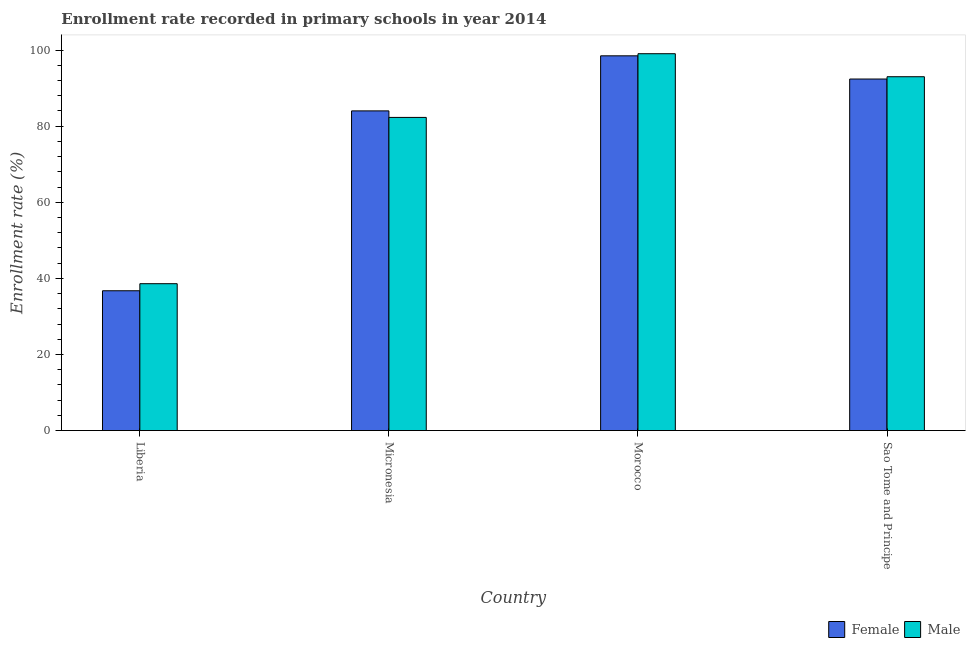How many different coloured bars are there?
Offer a terse response. 2. How many groups of bars are there?
Ensure brevity in your answer.  4. Are the number of bars per tick equal to the number of legend labels?
Make the answer very short. Yes. How many bars are there on the 3rd tick from the left?
Offer a very short reply. 2. How many bars are there on the 1st tick from the right?
Your response must be concise. 2. What is the label of the 4th group of bars from the left?
Keep it short and to the point. Sao Tome and Principe. In how many cases, is the number of bars for a given country not equal to the number of legend labels?
Make the answer very short. 0. What is the enrollment rate of male students in Micronesia?
Give a very brief answer. 82.29. Across all countries, what is the maximum enrollment rate of male students?
Provide a succinct answer. 99.03. Across all countries, what is the minimum enrollment rate of male students?
Give a very brief answer. 38.6. In which country was the enrollment rate of female students maximum?
Provide a succinct answer. Morocco. In which country was the enrollment rate of female students minimum?
Keep it short and to the point. Liberia. What is the total enrollment rate of male students in the graph?
Make the answer very short. 312.92. What is the difference between the enrollment rate of female students in Liberia and that in Sao Tome and Principe?
Provide a short and direct response. -55.64. What is the difference between the enrollment rate of female students in Micronesia and the enrollment rate of male students in Liberia?
Your answer should be very brief. 45.41. What is the average enrollment rate of female students per country?
Give a very brief answer. 77.9. What is the difference between the enrollment rate of male students and enrollment rate of female students in Micronesia?
Provide a short and direct response. -1.72. In how many countries, is the enrollment rate of male students greater than 4 %?
Your answer should be compact. 4. What is the ratio of the enrollment rate of male students in Micronesia to that in Morocco?
Make the answer very short. 0.83. Is the enrollment rate of male students in Morocco less than that in Sao Tome and Principe?
Your answer should be compact. No. What is the difference between the highest and the second highest enrollment rate of male students?
Your answer should be very brief. 6.05. What is the difference between the highest and the lowest enrollment rate of female students?
Give a very brief answer. 61.74. What does the 1st bar from the left in Sao Tome and Principe represents?
Ensure brevity in your answer.  Female. How many bars are there?
Offer a very short reply. 8. Are all the bars in the graph horizontal?
Keep it short and to the point. No. What is the difference between two consecutive major ticks on the Y-axis?
Your response must be concise. 20. Are the values on the major ticks of Y-axis written in scientific E-notation?
Ensure brevity in your answer.  No. How many legend labels are there?
Keep it short and to the point. 2. What is the title of the graph?
Offer a terse response. Enrollment rate recorded in primary schools in year 2014. What is the label or title of the Y-axis?
Give a very brief answer. Enrollment rate (%). What is the Enrollment rate (%) in Female in Liberia?
Make the answer very short. 36.74. What is the Enrollment rate (%) of Male in Liberia?
Provide a succinct answer. 38.6. What is the Enrollment rate (%) of Female in Micronesia?
Your response must be concise. 84.01. What is the Enrollment rate (%) in Male in Micronesia?
Give a very brief answer. 82.29. What is the Enrollment rate (%) in Female in Morocco?
Keep it short and to the point. 98.48. What is the Enrollment rate (%) in Male in Morocco?
Offer a very short reply. 99.03. What is the Enrollment rate (%) in Female in Sao Tome and Principe?
Ensure brevity in your answer.  92.38. What is the Enrollment rate (%) in Male in Sao Tome and Principe?
Give a very brief answer. 92.99. Across all countries, what is the maximum Enrollment rate (%) of Female?
Offer a very short reply. 98.48. Across all countries, what is the maximum Enrollment rate (%) of Male?
Give a very brief answer. 99.03. Across all countries, what is the minimum Enrollment rate (%) of Female?
Your response must be concise. 36.74. Across all countries, what is the minimum Enrollment rate (%) in Male?
Give a very brief answer. 38.6. What is the total Enrollment rate (%) in Female in the graph?
Provide a short and direct response. 311.62. What is the total Enrollment rate (%) in Male in the graph?
Provide a succinct answer. 312.92. What is the difference between the Enrollment rate (%) in Female in Liberia and that in Micronesia?
Give a very brief answer. -47.27. What is the difference between the Enrollment rate (%) of Male in Liberia and that in Micronesia?
Make the answer very short. -43.7. What is the difference between the Enrollment rate (%) of Female in Liberia and that in Morocco?
Offer a very short reply. -61.74. What is the difference between the Enrollment rate (%) of Male in Liberia and that in Morocco?
Provide a short and direct response. -60.43. What is the difference between the Enrollment rate (%) in Female in Liberia and that in Sao Tome and Principe?
Provide a succinct answer. -55.64. What is the difference between the Enrollment rate (%) in Male in Liberia and that in Sao Tome and Principe?
Your answer should be compact. -54.39. What is the difference between the Enrollment rate (%) in Female in Micronesia and that in Morocco?
Offer a terse response. -14.47. What is the difference between the Enrollment rate (%) in Male in Micronesia and that in Morocco?
Your response must be concise. -16.74. What is the difference between the Enrollment rate (%) in Female in Micronesia and that in Sao Tome and Principe?
Make the answer very short. -8.37. What is the difference between the Enrollment rate (%) in Male in Micronesia and that in Sao Tome and Principe?
Your answer should be very brief. -10.69. What is the difference between the Enrollment rate (%) in Female in Morocco and that in Sao Tome and Principe?
Make the answer very short. 6.1. What is the difference between the Enrollment rate (%) in Male in Morocco and that in Sao Tome and Principe?
Your answer should be compact. 6.05. What is the difference between the Enrollment rate (%) of Female in Liberia and the Enrollment rate (%) of Male in Micronesia?
Your answer should be very brief. -45.55. What is the difference between the Enrollment rate (%) of Female in Liberia and the Enrollment rate (%) of Male in Morocco?
Keep it short and to the point. -62.29. What is the difference between the Enrollment rate (%) of Female in Liberia and the Enrollment rate (%) of Male in Sao Tome and Principe?
Your answer should be compact. -56.24. What is the difference between the Enrollment rate (%) in Female in Micronesia and the Enrollment rate (%) in Male in Morocco?
Offer a very short reply. -15.02. What is the difference between the Enrollment rate (%) of Female in Micronesia and the Enrollment rate (%) of Male in Sao Tome and Principe?
Make the answer very short. -8.98. What is the difference between the Enrollment rate (%) of Female in Morocco and the Enrollment rate (%) of Male in Sao Tome and Principe?
Keep it short and to the point. 5.49. What is the average Enrollment rate (%) in Female per country?
Your answer should be compact. 77.9. What is the average Enrollment rate (%) in Male per country?
Provide a succinct answer. 78.23. What is the difference between the Enrollment rate (%) in Female and Enrollment rate (%) in Male in Liberia?
Your answer should be compact. -1.86. What is the difference between the Enrollment rate (%) in Female and Enrollment rate (%) in Male in Micronesia?
Your response must be concise. 1.72. What is the difference between the Enrollment rate (%) in Female and Enrollment rate (%) in Male in Morocco?
Provide a succinct answer. -0.55. What is the difference between the Enrollment rate (%) in Female and Enrollment rate (%) in Male in Sao Tome and Principe?
Give a very brief answer. -0.61. What is the ratio of the Enrollment rate (%) in Female in Liberia to that in Micronesia?
Ensure brevity in your answer.  0.44. What is the ratio of the Enrollment rate (%) in Male in Liberia to that in Micronesia?
Give a very brief answer. 0.47. What is the ratio of the Enrollment rate (%) in Female in Liberia to that in Morocco?
Provide a short and direct response. 0.37. What is the ratio of the Enrollment rate (%) in Male in Liberia to that in Morocco?
Provide a short and direct response. 0.39. What is the ratio of the Enrollment rate (%) of Female in Liberia to that in Sao Tome and Principe?
Your answer should be compact. 0.4. What is the ratio of the Enrollment rate (%) in Male in Liberia to that in Sao Tome and Principe?
Ensure brevity in your answer.  0.42. What is the ratio of the Enrollment rate (%) of Female in Micronesia to that in Morocco?
Offer a terse response. 0.85. What is the ratio of the Enrollment rate (%) in Male in Micronesia to that in Morocco?
Your answer should be very brief. 0.83. What is the ratio of the Enrollment rate (%) in Female in Micronesia to that in Sao Tome and Principe?
Offer a terse response. 0.91. What is the ratio of the Enrollment rate (%) in Male in Micronesia to that in Sao Tome and Principe?
Offer a terse response. 0.89. What is the ratio of the Enrollment rate (%) in Female in Morocco to that in Sao Tome and Principe?
Provide a short and direct response. 1.07. What is the ratio of the Enrollment rate (%) in Male in Morocco to that in Sao Tome and Principe?
Provide a short and direct response. 1.06. What is the difference between the highest and the second highest Enrollment rate (%) of Female?
Provide a short and direct response. 6.1. What is the difference between the highest and the second highest Enrollment rate (%) of Male?
Your answer should be compact. 6.05. What is the difference between the highest and the lowest Enrollment rate (%) of Female?
Give a very brief answer. 61.74. What is the difference between the highest and the lowest Enrollment rate (%) of Male?
Offer a terse response. 60.43. 